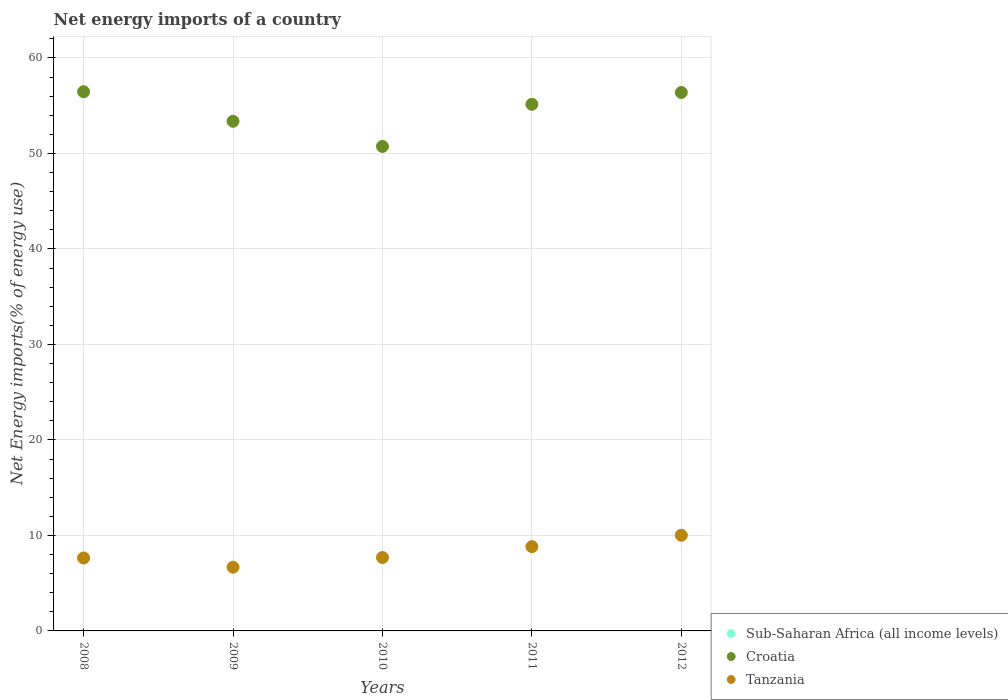How many different coloured dotlines are there?
Your answer should be compact. 2. What is the net energy imports in Croatia in 2012?
Give a very brief answer. 56.38. Across all years, what is the maximum net energy imports in Tanzania?
Ensure brevity in your answer.  10.02. Across all years, what is the minimum net energy imports in Sub-Saharan Africa (all income levels)?
Ensure brevity in your answer.  0. In which year was the net energy imports in Tanzania maximum?
Your response must be concise. 2012. What is the total net energy imports in Croatia in the graph?
Provide a succinct answer. 272.08. What is the difference between the net energy imports in Croatia in 2011 and that in 2012?
Keep it short and to the point. -1.24. What is the difference between the net energy imports in Tanzania in 2011 and the net energy imports in Sub-Saharan Africa (all income levels) in 2009?
Make the answer very short. 8.83. What is the average net energy imports in Tanzania per year?
Provide a succinct answer. 8.17. In the year 2009, what is the difference between the net energy imports in Croatia and net energy imports in Tanzania?
Your response must be concise. 46.69. What is the ratio of the net energy imports in Tanzania in 2008 to that in 2011?
Provide a short and direct response. 0.87. Is the net energy imports in Croatia in 2011 less than that in 2012?
Give a very brief answer. Yes. What is the difference between the highest and the second highest net energy imports in Croatia?
Provide a succinct answer. 0.08. What is the difference between the highest and the lowest net energy imports in Tanzania?
Your answer should be compact. 3.34. Is the sum of the net energy imports in Croatia in 2008 and 2010 greater than the maximum net energy imports in Sub-Saharan Africa (all income levels) across all years?
Offer a very short reply. Yes. Is the net energy imports in Sub-Saharan Africa (all income levels) strictly less than the net energy imports in Croatia over the years?
Offer a very short reply. Yes. How many dotlines are there?
Ensure brevity in your answer.  2. What is the difference between two consecutive major ticks on the Y-axis?
Your answer should be very brief. 10. Are the values on the major ticks of Y-axis written in scientific E-notation?
Provide a succinct answer. No. Does the graph contain grids?
Give a very brief answer. Yes. Where does the legend appear in the graph?
Your answer should be very brief. Bottom right. How many legend labels are there?
Make the answer very short. 3. How are the legend labels stacked?
Provide a short and direct response. Vertical. What is the title of the graph?
Keep it short and to the point. Net energy imports of a country. Does "Liechtenstein" appear as one of the legend labels in the graph?
Give a very brief answer. No. What is the label or title of the X-axis?
Give a very brief answer. Years. What is the label or title of the Y-axis?
Offer a terse response. Net Energy imports(% of energy use). What is the Net Energy imports(% of energy use) of Croatia in 2008?
Ensure brevity in your answer.  56.46. What is the Net Energy imports(% of energy use) of Tanzania in 2008?
Offer a very short reply. 7.64. What is the Net Energy imports(% of energy use) of Sub-Saharan Africa (all income levels) in 2009?
Provide a succinct answer. 0. What is the Net Energy imports(% of energy use) in Croatia in 2009?
Your answer should be very brief. 53.37. What is the Net Energy imports(% of energy use) of Tanzania in 2009?
Provide a succinct answer. 6.67. What is the Net Energy imports(% of energy use) in Croatia in 2010?
Make the answer very short. 50.73. What is the Net Energy imports(% of energy use) in Tanzania in 2010?
Your answer should be very brief. 7.69. What is the Net Energy imports(% of energy use) in Croatia in 2011?
Keep it short and to the point. 55.14. What is the Net Energy imports(% of energy use) in Tanzania in 2011?
Your answer should be very brief. 8.83. What is the Net Energy imports(% of energy use) in Sub-Saharan Africa (all income levels) in 2012?
Give a very brief answer. 0. What is the Net Energy imports(% of energy use) of Croatia in 2012?
Your response must be concise. 56.38. What is the Net Energy imports(% of energy use) in Tanzania in 2012?
Give a very brief answer. 10.02. Across all years, what is the maximum Net Energy imports(% of energy use) in Croatia?
Make the answer very short. 56.46. Across all years, what is the maximum Net Energy imports(% of energy use) of Tanzania?
Your answer should be compact. 10.02. Across all years, what is the minimum Net Energy imports(% of energy use) of Croatia?
Give a very brief answer. 50.73. Across all years, what is the minimum Net Energy imports(% of energy use) in Tanzania?
Ensure brevity in your answer.  6.67. What is the total Net Energy imports(% of energy use) in Croatia in the graph?
Provide a short and direct response. 272.08. What is the total Net Energy imports(% of energy use) of Tanzania in the graph?
Your response must be concise. 40.84. What is the difference between the Net Energy imports(% of energy use) of Croatia in 2008 and that in 2009?
Give a very brief answer. 3.09. What is the difference between the Net Energy imports(% of energy use) of Tanzania in 2008 and that in 2009?
Provide a succinct answer. 0.96. What is the difference between the Net Energy imports(% of energy use) of Croatia in 2008 and that in 2010?
Ensure brevity in your answer.  5.73. What is the difference between the Net Energy imports(% of energy use) of Tanzania in 2008 and that in 2010?
Your response must be concise. -0.05. What is the difference between the Net Energy imports(% of energy use) of Croatia in 2008 and that in 2011?
Your answer should be very brief. 1.31. What is the difference between the Net Energy imports(% of energy use) in Tanzania in 2008 and that in 2011?
Provide a succinct answer. -1.19. What is the difference between the Net Energy imports(% of energy use) of Croatia in 2008 and that in 2012?
Keep it short and to the point. 0.08. What is the difference between the Net Energy imports(% of energy use) of Tanzania in 2008 and that in 2012?
Your response must be concise. -2.38. What is the difference between the Net Energy imports(% of energy use) in Croatia in 2009 and that in 2010?
Make the answer very short. 2.64. What is the difference between the Net Energy imports(% of energy use) in Tanzania in 2009 and that in 2010?
Keep it short and to the point. -1.02. What is the difference between the Net Energy imports(% of energy use) of Croatia in 2009 and that in 2011?
Your answer should be compact. -1.78. What is the difference between the Net Energy imports(% of energy use) of Tanzania in 2009 and that in 2011?
Your answer should be compact. -2.15. What is the difference between the Net Energy imports(% of energy use) of Croatia in 2009 and that in 2012?
Give a very brief answer. -3.02. What is the difference between the Net Energy imports(% of energy use) in Tanzania in 2009 and that in 2012?
Give a very brief answer. -3.34. What is the difference between the Net Energy imports(% of energy use) in Croatia in 2010 and that in 2011?
Provide a short and direct response. -4.41. What is the difference between the Net Energy imports(% of energy use) of Tanzania in 2010 and that in 2011?
Provide a short and direct response. -1.14. What is the difference between the Net Energy imports(% of energy use) in Croatia in 2010 and that in 2012?
Offer a very short reply. -5.65. What is the difference between the Net Energy imports(% of energy use) of Tanzania in 2010 and that in 2012?
Offer a very short reply. -2.33. What is the difference between the Net Energy imports(% of energy use) of Croatia in 2011 and that in 2012?
Offer a very short reply. -1.24. What is the difference between the Net Energy imports(% of energy use) of Tanzania in 2011 and that in 2012?
Your answer should be very brief. -1.19. What is the difference between the Net Energy imports(% of energy use) in Croatia in 2008 and the Net Energy imports(% of energy use) in Tanzania in 2009?
Provide a succinct answer. 49.79. What is the difference between the Net Energy imports(% of energy use) of Croatia in 2008 and the Net Energy imports(% of energy use) of Tanzania in 2010?
Give a very brief answer. 48.77. What is the difference between the Net Energy imports(% of energy use) of Croatia in 2008 and the Net Energy imports(% of energy use) of Tanzania in 2011?
Provide a short and direct response. 47.63. What is the difference between the Net Energy imports(% of energy use) in Croatia in 2008 and the Net Energy imports(% of energy use) in Tanzania in 2012?
Make the answer very short. 46.44. What is the difference between the Net Energy imports(% of energy use) in Croatia in 2009 and the Net Energy imports(% of energy use) in Tanzania in 2010?
Keep it short and to the point. 45.68. What is the difference between the Net Energy imports(% of energy use) of Croatia in 2009 and the Net Energy imports(% of energy use) of Tanzania in 2011?
Provide a short and direct response. 44.54. What is the difference between the Net Energy imports(% of energy use) in Croatia in 2009 and the Net Energy imports(% of energy use) in Tanzania in 2012?
Ensure brevity in your answer.  43.35. What is the difference between the Net Energy imports(% of energy use) of Croatia in 2010 and the Net Energy imports(% of energy use) of Tanzania in 2011?
Provide a short and direct response. 41.9. What is the difference between the Net Energy imports(% of energy use) of Croatia in 2010 and the Net Energy imports(% of energy use) of Tanzania in 2012?
Ensure brevity in your answer.  40.71. What is the difference between the Net Energy imports(% of energy use) of Croatia in 2011 and the Net Energy imports(% of energy use) of Tanzania in 2012?
Ensure brevity in your answer.  45.13. What is the average Net Energy imports(% of energy use) of Croatia per year?
Your answer should be very brief. 54.42. What is the average Net Energy imports(% of energy use) of Tanzania per year?
Your answer should be very brief. 8.17. In the year 2008, what is the difference between the Net Energy imports(% of energy use) in Croatia and Net Energy imports(% of energy use) in Tanzania?
Your answer should be very brief. 48.82. In the year 2009, what is the difference between the Net Energy imports(% of energy use) in Croatia and Net Energy imports(% of energy use) in Tanzania?
Give a very brief answer. 46.69. In the year 2010, what is the difference between the Net Energy imports(% of energy use) in Croatia and Net Energy imports(% of energy use) in Tanzania?
Offer a terse response. 43.04. In the year 2011, what is the difference between the Net Energy imports(% of energy use) of Croatia and Net Energy imports(% of energy use) of Tanzania?
Give a very brief answer. 46.32. In the year 2012, what is the difference between the Net Energy imports(% of energy use) in Croatia and Net Energy imports(% of energy use) in Tanzania?
Keep it short and to the point. 46.37. What is the ratio of the Net Energy imports(% of energy use) of Croatia in 2008 to that in 2009?
Keep it short and to the point. 1.06. What is the ratio of the Net Energy imports(% of energy use) in Tanzania in 2008 to that in 2009?
Provide a succinct answer. 1.14. What is the ratio of the Net Energy imports(% of energy use) in Croatia in 2008 to that in 2010?
Give a very brief answer. 1.11. What is the ratio of the Net Energy imports(% of energy use) in Croatia in 2008 to that in 2011?
Your answer should be very brief. 1.02. What is the ratio of the Net Energy imports(% of energy use) of Tanzania in 2008 to that in 2011?
Your answer should be compact. 0.87. What is the ratio of the Net Energy imports(% of energy use) in Tanzania in 2008 to that in 2012?
Make the answer very short. 0.76. What is the ratio of the Net Energy imports(% of energy use) of Croatia in 2009 to that in 2010?
Ensure brevity in your answer.  1.05. What is the ratio of the Net Energy imports(% of energy use) in Tanzania in 2009 to that in 2010?
Offer a very short reply. 0.87. What is the ratio of the Net Energy imports(% of energy use) of Croatia in 2009 to that in 2011?
Make the answer very short. 0.97. What is the ratio of the Net Energy imports(% of energy use) of Tanzania in 2009 to that in 2011?
Keep it short and to the point. 0.76. What is the ratio of the Net Energy imports(% of energy use) of Croatia in 2009 to that in 2012?
Provide a short and direct response. 0.95. What is the ratio of the Net Energy imports(% of energy use) of Tanzania in 2009 to that in 2012?
Your answer should be compact. 0.67. What is the ratio of the Net Energy imports(% of energy use) of Tanzania in 2010 to that in 2011?
Offer a very short reply. 0.87. What is the ratio of the Net Energy imports(% of energy use) in Croatia in 2010 to that in 2012?
Give a very brief answer. 0.9. What is the ratio of the Net Energy imports(% of energy use) in Tanzania in 2010 to that in 2012?
Offer a terse response. 0.77. What is the ratio of the Net Energy imports(% of energy use) in Croatia in 2011 to that in 2012?
Your answer should be compact. 0.98. What is the ratio of the Net Energy imports(% of energy use) of Tanzania in 2011 to that in 2012?
Offer a terse response. 0.88. What is the difference between the highest and the second highest Net Energy imports(% of energy use) in Croatia?
Your answer should be compact. 0.08. What is the difference between the highest and the second highest Net Energy imports(% of energy use) in Tanzania?
Give a very brief answer. 1.19. What is the difference between the highest and the lowest Net Energy imports(% of energy use) in Croatia?
Your answer should be very brief. 5.73. What is the difference between the highest and the lowest Net Energy imports(% of energy use) of Tanzania?
Offer a very short reply. 3.34. 